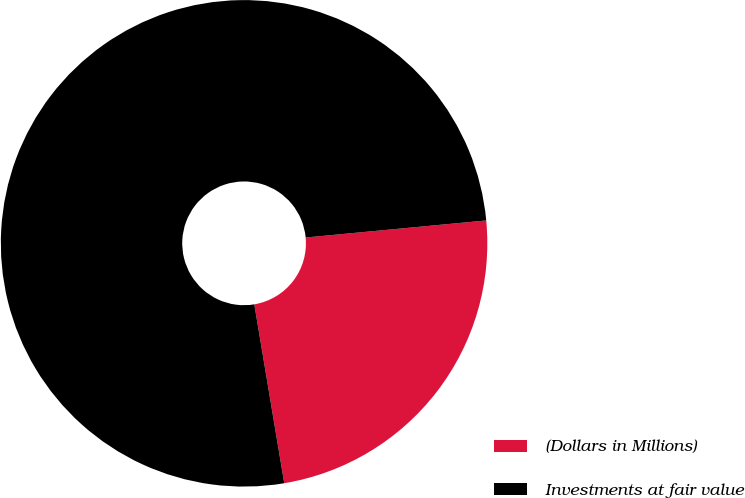<chart> <loc_0><loc_0><loc_500><loc_500><pie_chart><fcel>(Dollars in Millions)<fcel>Investments at fair value<nl><fcel>23.86%<fcel>76.14%<nl></chart> 